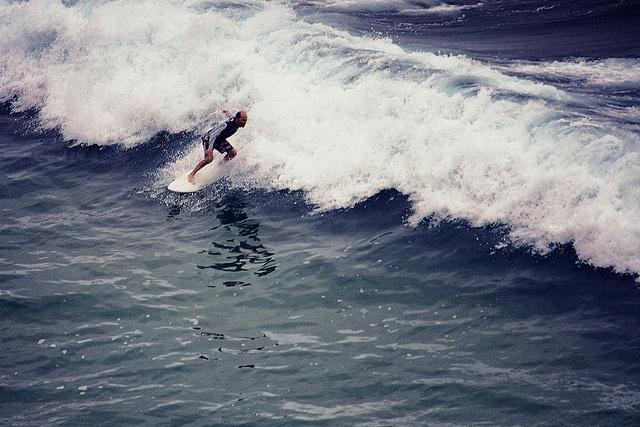How many people are in this photo?
Give a very brief answer. 1. 